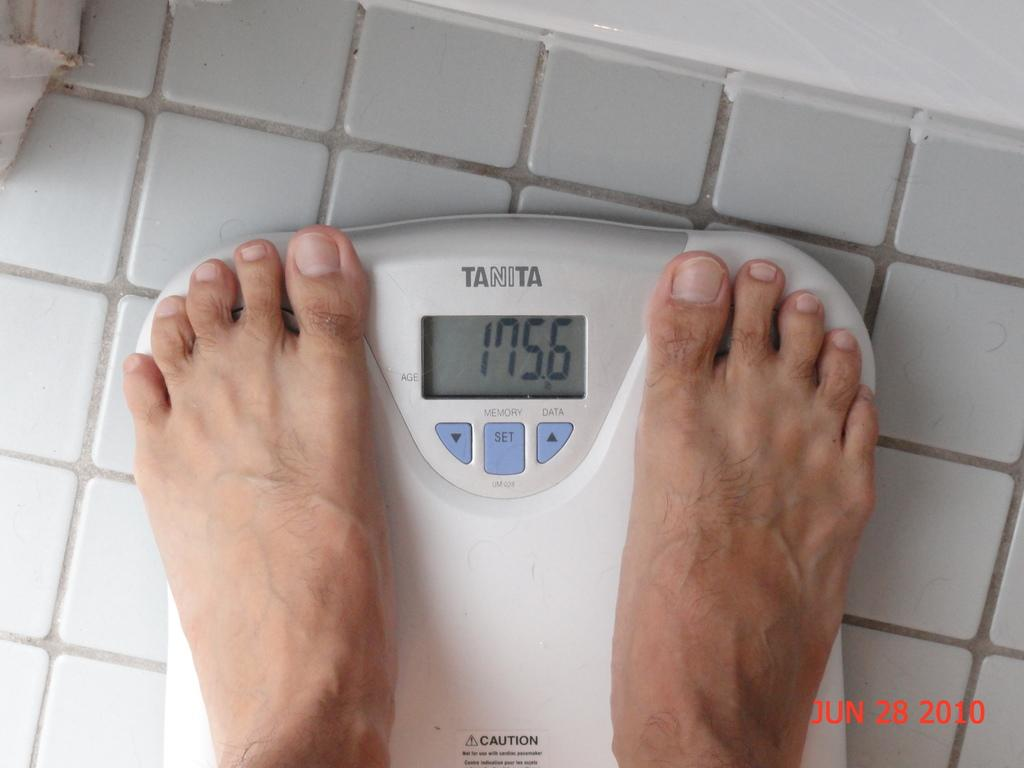What object is present in the image that is used for measuring weight? There is a weighing machine in the image. What is placed on the weighing machine? Human legs are on the weighing machine. What feature is visible on the weighing machine? There is a screen visible in the image. How many ducks are swimming in the cloud in the image? There are no ducks or clouds present in the image. 